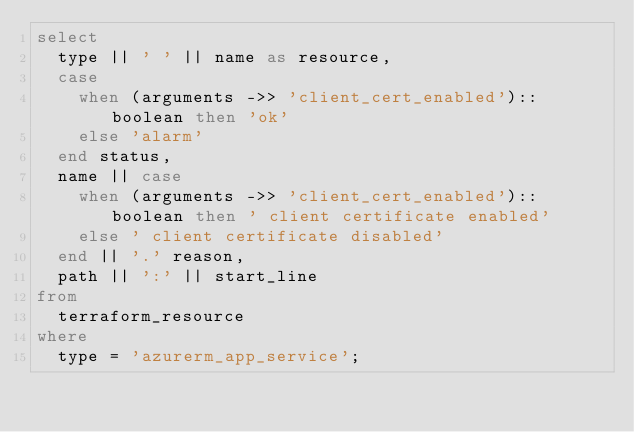<code> <loc_0><loc_0><loc_500><loc_500><_SQL_>select
  type || ' ' || name as resource,
  case
    when (arguments ->> 'client_cert_enabled')::boolean then 'ok'
    else 'alarm'
  end status,
  name || case
    when (arguments ->> 'client_cert_enabled')::boolean then ' client certificate enabled'
    else ' client certificate disabled'
  end || '.' reason,
  path || ':' || start_line
from
  terraform_resource
where
  type = 'azurerm_app_service';</code> 